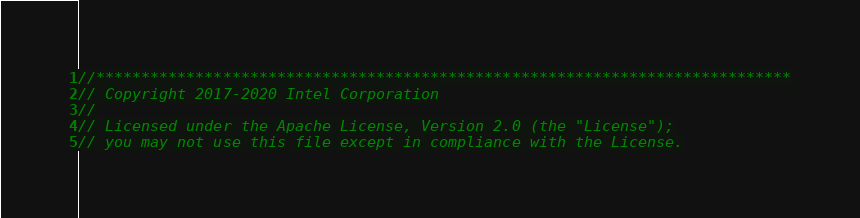Convert code to text. <code><loc_0><loc_0><loc_500><loc_500><_C++_>//*****************************************************************************
// Copyright 2017-2020 Intel Corporation
//
// Licensed under the Apache License, Version 2.0 (the "License");
// you may not use this file except in compliance with the License.</code> 